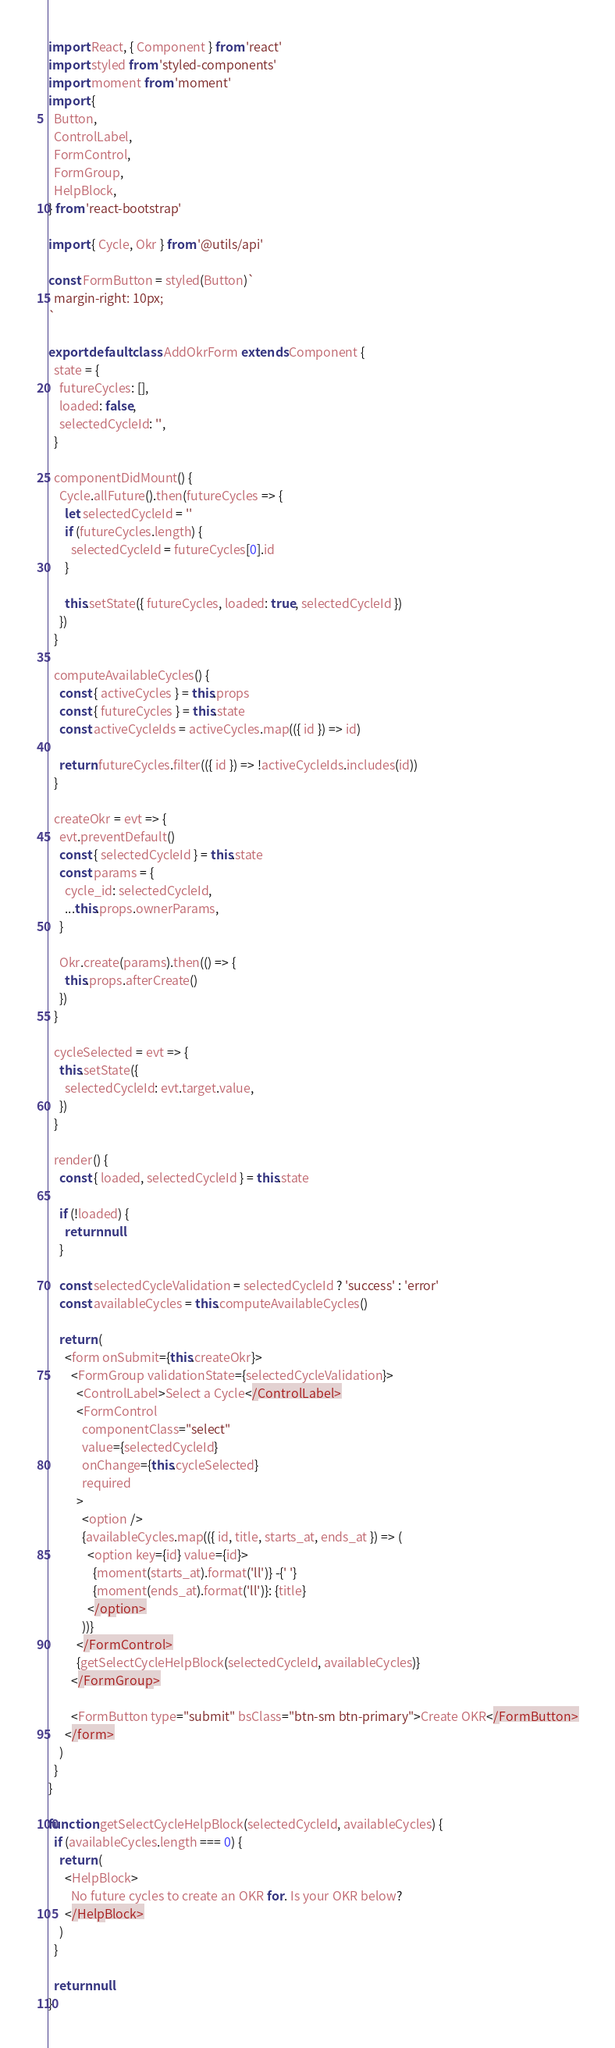Convert code to text. <code><loc_0><loc_0><loc_500><loc_500><_JavaScript_>import React, { Component } from 'react'
import styled from 'styled-components'
import moment from 'moment'
import {
  Button,
  ControlLabel,
  FormControl,
  FormGroup,
  HelpBlock,
} from 'react-bootstrap'

import { Cycle, Okr } from '@utils/api'

const FormButton = styled(Button)`
  margin-right: 10px;
`

export default class AddOkrForm extends Component {
  state = {
    futureCycles: [],
    loaded: false,
    selectedCycleId: '',
  }

  componentDidMount() {
    Cycle.allFuture().then(futureCycles => {
      let selectedCycleId = ''
      if (futureCycles.length) {
        selectedCycleId = futureCycles[0].id
      }

      this.setState({ futureCycles, loaded: true, selectedCycleId })
    })
  }

  computeAvailableCycles() {
    const { activeCycles } = this.props
    const { futureCycles } = this.state
    const activeCycleIds = activeCycles.map(({ id }) => id)

    return futureCycles.filter(({ id }) => !activeCycleIds.includes(id))
  }

  createOkr = evt => {
    evt.preventDefault()
    const { selectedCycleId } = this.state
    const params = {
      cycle_id: selectedCycleId,
      ...this.props.ownerParams,
    }

    Okr.create(params).then(() => {
      this.props.afterCreate()
    })
  }

  cycleSelected = evt => {
    this.setState({
      selectedCycleId: evt.target.value,
    })
  }

  render() {
    const { loaded, selectedCycleId } = this.state

    if (!loaded) {
      return null
    }

    const selectedCycleValidation = selectedCycleId ? 'success' : 'error'
    const availableCycles = this.computeAvailableCycles()

    return (
      <form onSubmit={this.createOkr}>
        <FormGroup validationState={selectedCycleValidation}>
          <ControlLabel>Select a Cycle</ControlLabel>
          <FormControl
            componentClass="select"
            value={selectedCycleId}
            onChange={this.cycleSelected}
            required
          >
            <option />
            {availableCycles.map(({ id, title, starts_at, ends_at }) => (
              <option key={id} value={id}>
                {moment(starts_at).format('ll')} -{' '}
                {moment(ends_at).format('ll')}: {title}
              </option>
            ))}
          </FormControl>
          {getSelectCycleHelpBlock(selectedCycleId, availableCycles)}
        </FormGroup>

        <FormButton type="submit" bsClass="btn-sm btn-primary">Create OKR</FormButton>
      </form>
    )
  }
}

function getSelectCycleHelpBlock(selectedCycleId, availableCycles) {
  if (availableCycles.length === 0) {
    return (
      <HelpBlock>
        No future cycles to create an OKR for. Is your OKR below?
      </HelpBlock>
    )
  }

  return null
}
</code> 